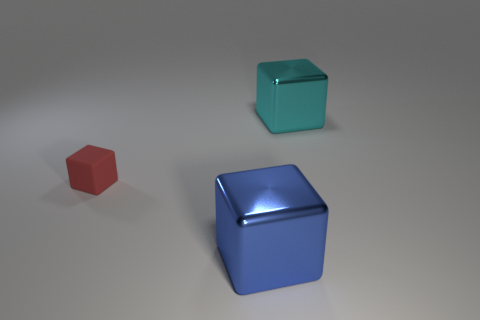How many large blue objects are there?
Your response must be concise. 1. The cyan object that is the same shape as the tiny red object is what size?
Provide a short and direct response. Large. There is a big thing behind the red cube; is its shape the same as the big blue metallic object?
Keep it short and to the point. Yes. What is the color of the large shiny cube that is behind the red thing?
Provide a succinct answer. Cyan. What number of other objects are there of the same size as the blue block?
Provide a short and direct response. 1. Is there anything else that is the same shape as the red object?
Keep it short and to the point. Yes. Are there an equal number of things right of the red block and blocks?
Ensure brevity in your answer.  No. How many tiny red objects are made of the same material as the large cyan cube?
Provide a short and direct response. 0. What color is the other big cube that is made of the same material as the blue cube?
Provide a short and direct response. Cyan. Do the blue shiny thing and the red matte thing have the same shape?
Give a very brief answer. Yes. 